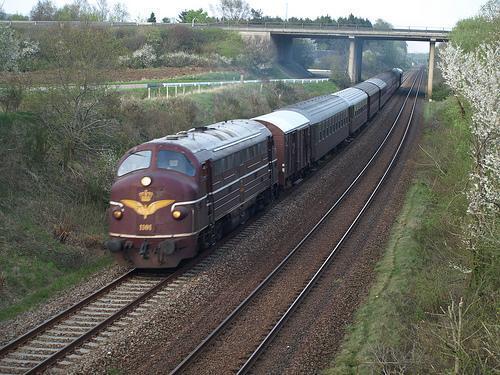How many trains are in the picture?
Give a very brief answer. 1. How many different colors does the front of the train have?
Give a very brief answer. 2. How many windows does the front of the train have?
Give a very brief answer. 2. How many sets of train tracks are there?
Give a very brief answer. 2. 